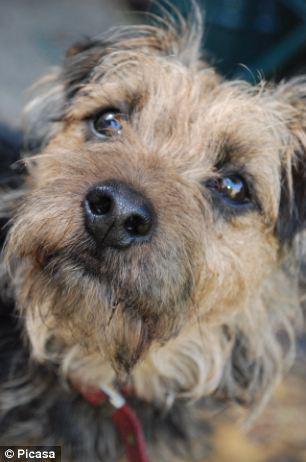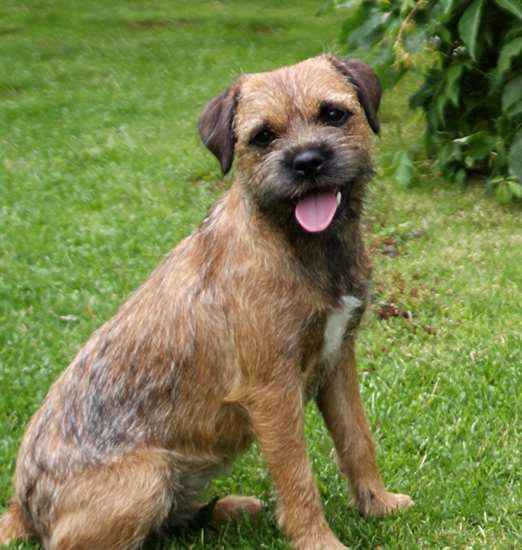The first image is the image on the left, the second image is the image on the right. For the images shown, is this caption "One dog is sitting in the grass." true? Answer yes or no. Yes. The first image is the image on the left, the second image is the image on the right. Evaluate the accuracy of this statement regarding the images: "One dog's tongue is hanging out of its mouth.". Is it true? Answer yes or no. Yes. 